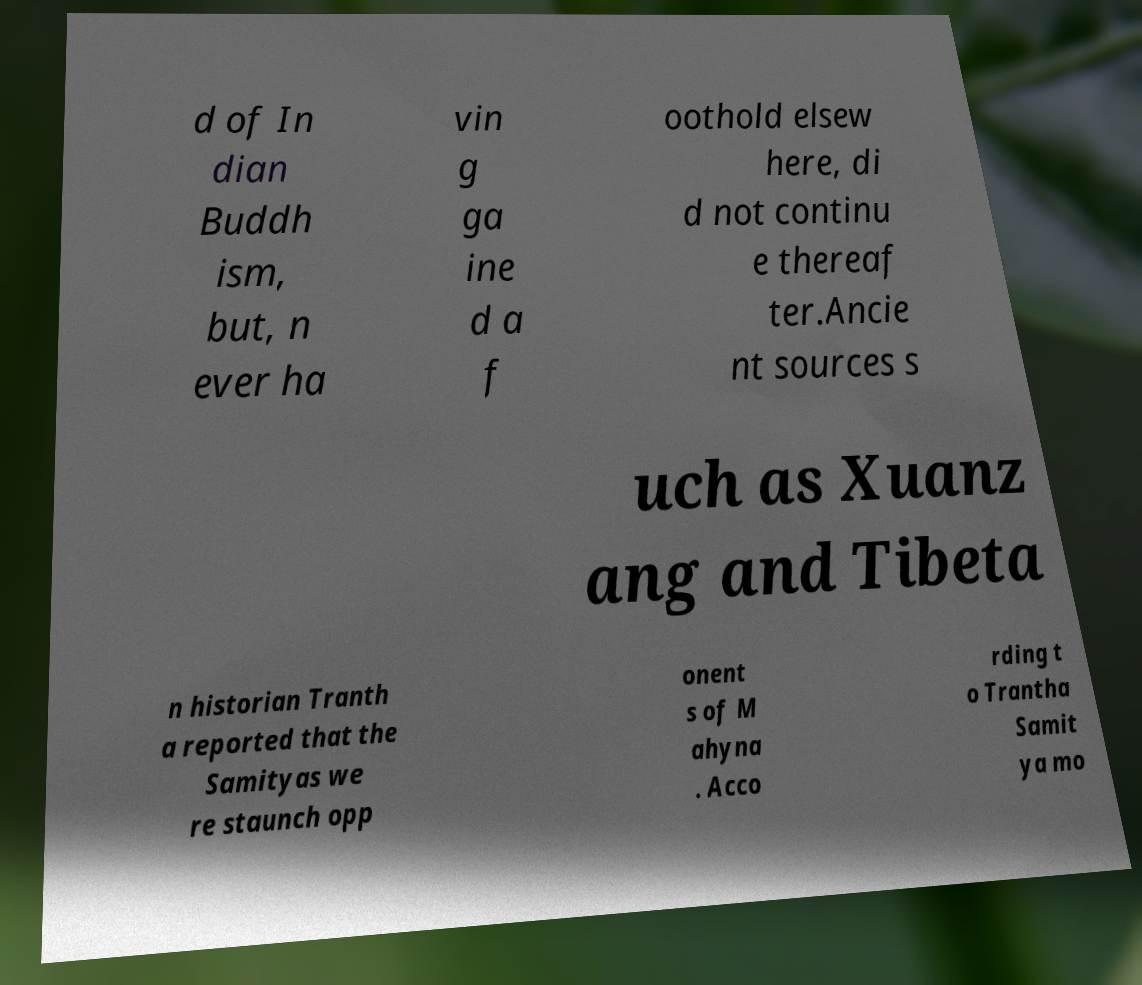What messages or text are displayed in this image? I need them in a readable, typed format. d of In dian Buddh ism, but, n ever ha vin g ga ine d a f oothold elsew here, di d not continu e thereaf ter.Ancie nt sources s uch as Xuanz ang and Tibeta n historian Tranth a reported that the Samityas we re staunch opp onent s of M ahyna . Acco rding t o Trantha Samit ya mo 